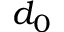Convert formula to latex. <formula><loc_0><loc_0><loc_500><loc_500>d _ { 0 }</formula> 